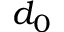Convert formula to latex. <formula><loc_0><loc_0><loc_500><loc_500>d _ { 0 }</formula> 